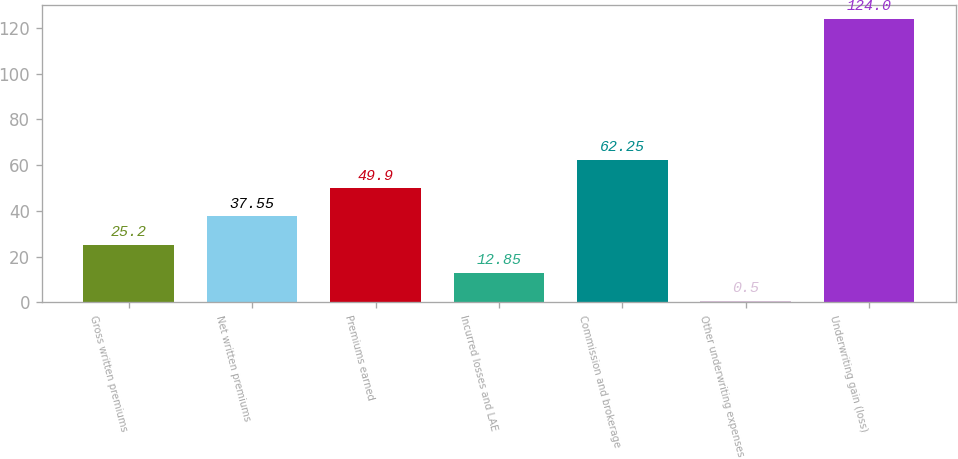Convert chart to OTSL. <chart><loc_0><loc_0><loc_500><loc_500><bar_chart><fcel>Gross written premiums<fcel>Net written premiums<fcel>Premiums earned<fcel>Incurred losses and LAE<fcel>Commission and brokerage<fcel>Other underwriting expenses<fcel>Underwriting gain (loss)<nl><fcel>25.2<fcel>37.55<fcel>49.9<fcel>12.85<fcel>62.25<fcel>0.5<fcel>124<nl></chart> 